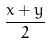<formula> <loc_0><loc_0><loc_500><loc_500>\frac { x + y } { 2 }</formula> 